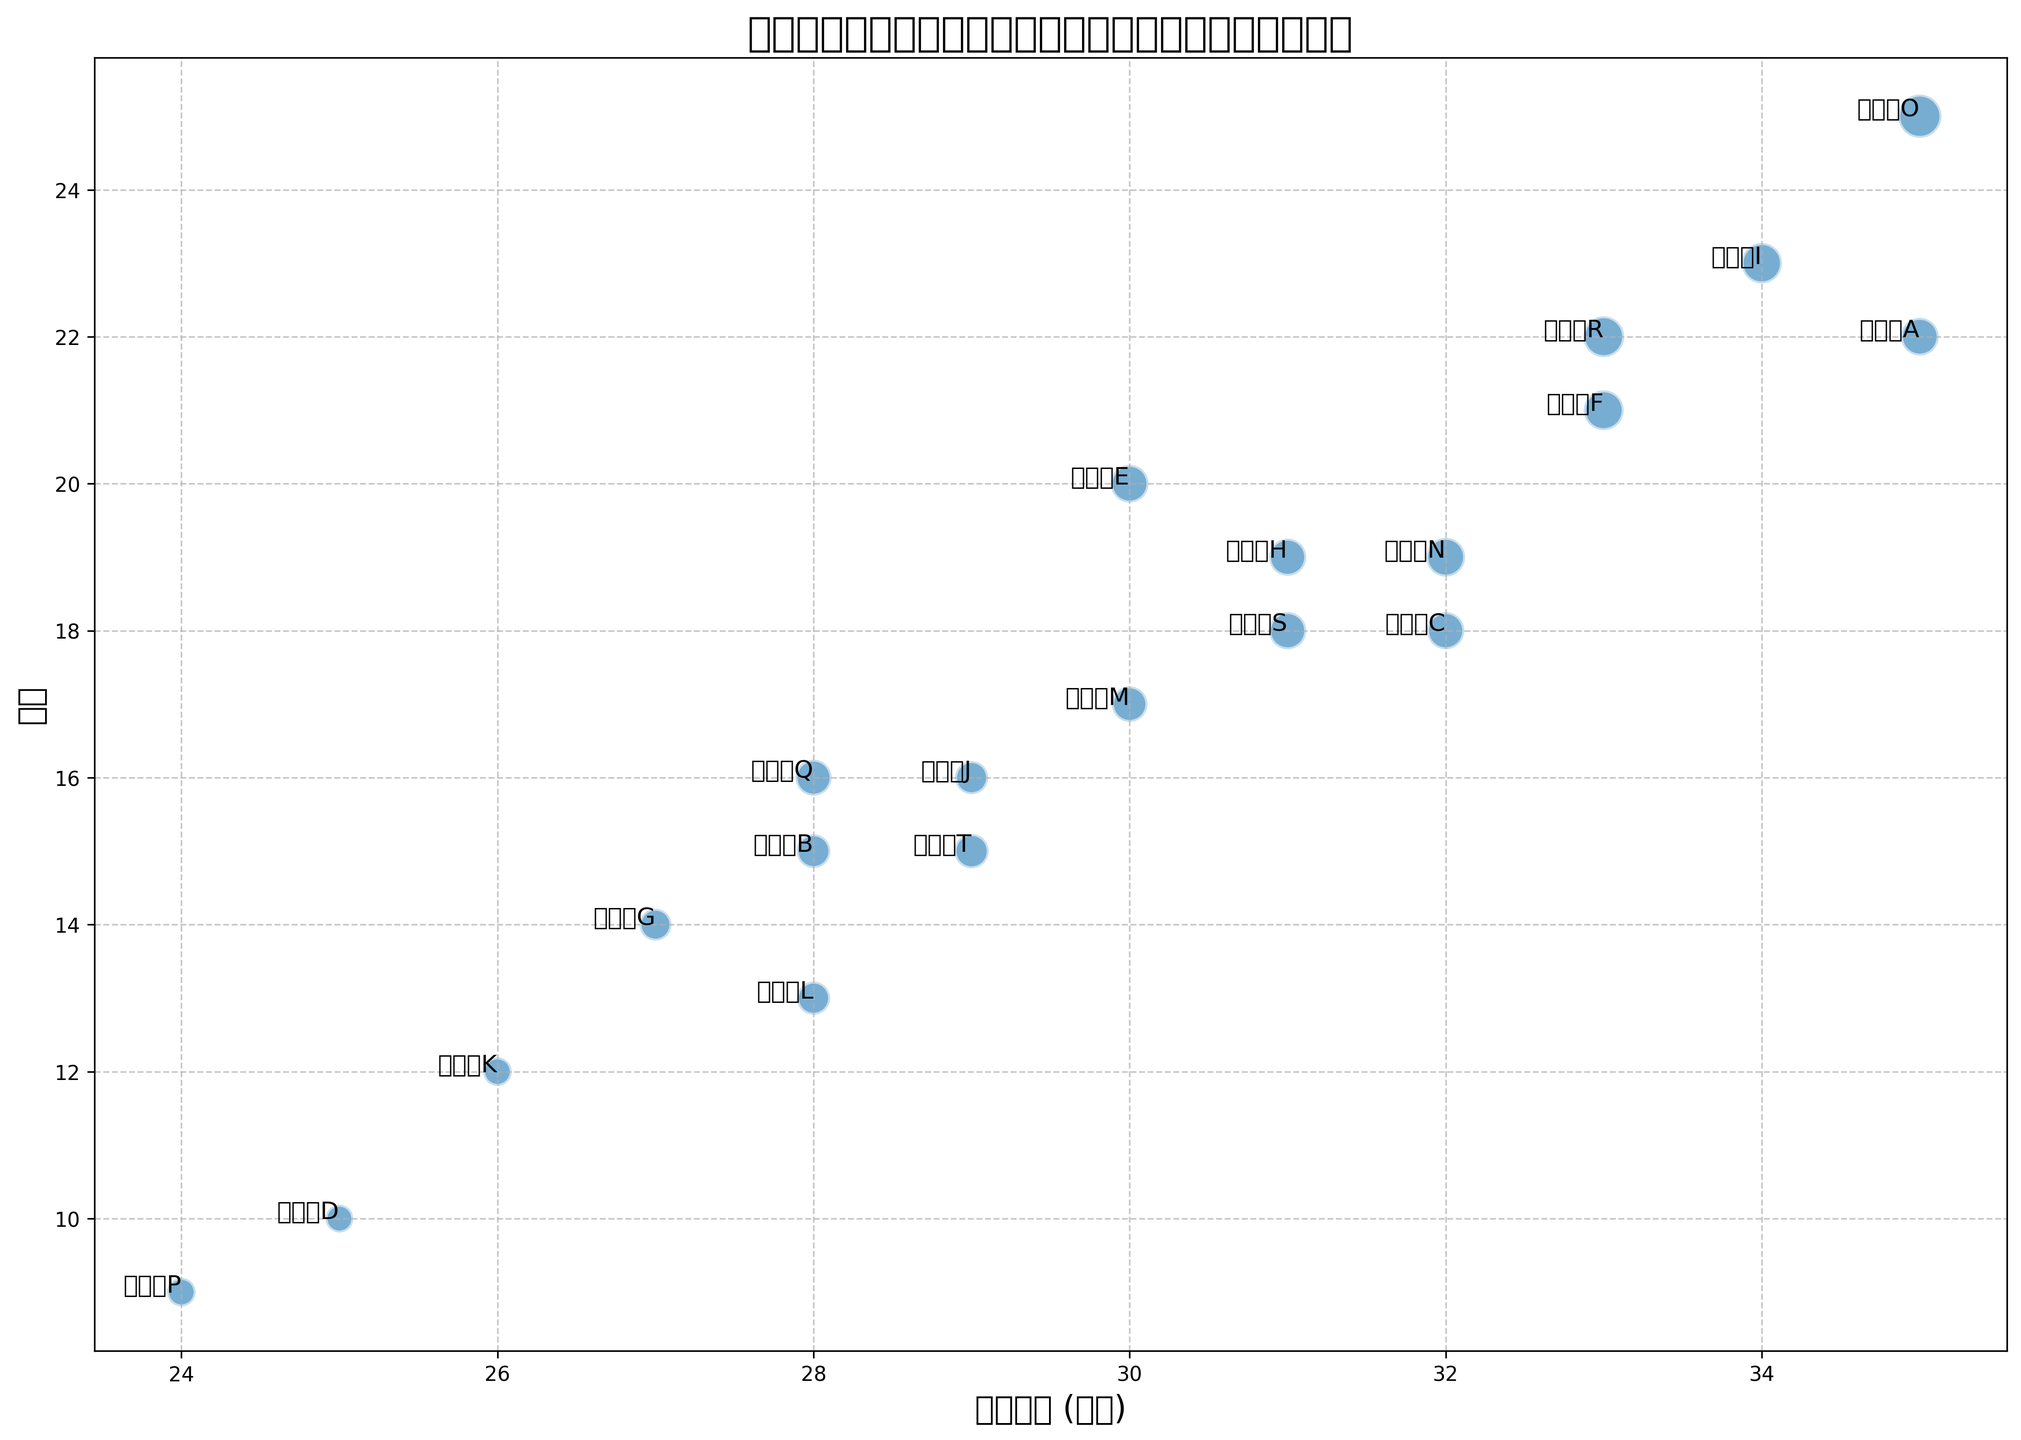哪位球员在比赛中出场时间最多，同时得分最高？ 从图表中，我们观察到运动员O的泡泡位于出场时间和得分坐标轴的最高位置。由此，我们可以确知运动员O在比赛中出场时间最长，并且得分最高。
Answer: 运动员O 哪个球员的出场时间和效能（得分+助攻+篮板）综合表现最好？ 图中我们可以看到，运动员O的泡泡最大且位置最高，表明他得分、助攻和篮板的总和最大。因此，运动员O的综合效能最好。
Answer: 运动员O 出场时间在30分钟以上且得分在20分以上的球员有哪些？ 通过观察图表，找到同时满足出场时间大于30分钟且得分大于20分的球员。这些泡泡包括运动员O和I。
Answer: 运动员O, 运动员I 哪个球员以最少的出场时间取得最多的得分？ 我们需要找出对应较小泡泡位置并且得分较高的运动员。运动员E是得分20的选手中出场时间最短的（30分钟）。
Answer: 运动员E 哪个球员的得分和助攻综合表现最好？ 我们寻找得分和助攻数较高的球员，根据图表，运动员O的泡泡最大且得分最高，表示他在得分和助攻上都表现最佳。运动员F和运动员R次之，但综合效果不如运动员O。
Answer: 运动员O 